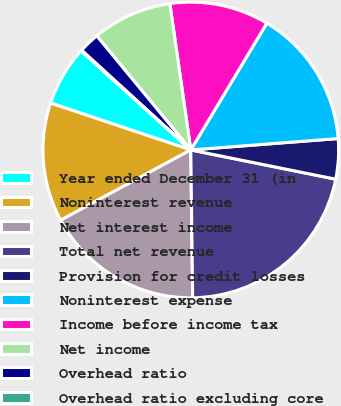Convert chart. <chart><loc_0><loc_0><loc_500><loc_500><pie_chart><fcel>Year ended December 31 (in<fcel>Noninterest revenue<fcel>Net interest income<fcel>Total net revenue<fcel>Provision for credit losses<fcel>Noninterest expense<fcel>Income before income tax<fcel>Net income<fcel>Overhead ratio<fcel>Overhead ratio excluding core<nl><fcel>6.55%<fcel>13.02%<fcel>17.32%<fcel>21.63%<fcel>4.4%<fcel>15.17%<fcel>10.86%<fcel>8.71%<fcel>2.25%<fcel>0.09%<nl></chart> 